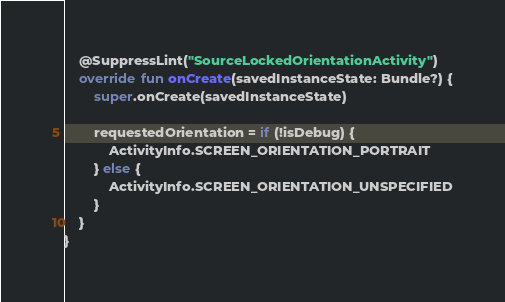<code> <loc_0><loc_0><loc_500><loc_500><_Kotlin_>
    @SuppressLint("SourceLockedOrientationActivity")
    override fun onCreate(savedInstanceState: Bundle?) {
        super.onCreate(savedInstanceState)

        requestedOrientation = if (!isDebug) {
            ActivityInfo.SCREEN_ORIENTATION_PORTRAIT
        } else {
            ActivityInfo.SCREEN_ORIENTATION_UNSPECIFIED
        }
    }
}
</code> 